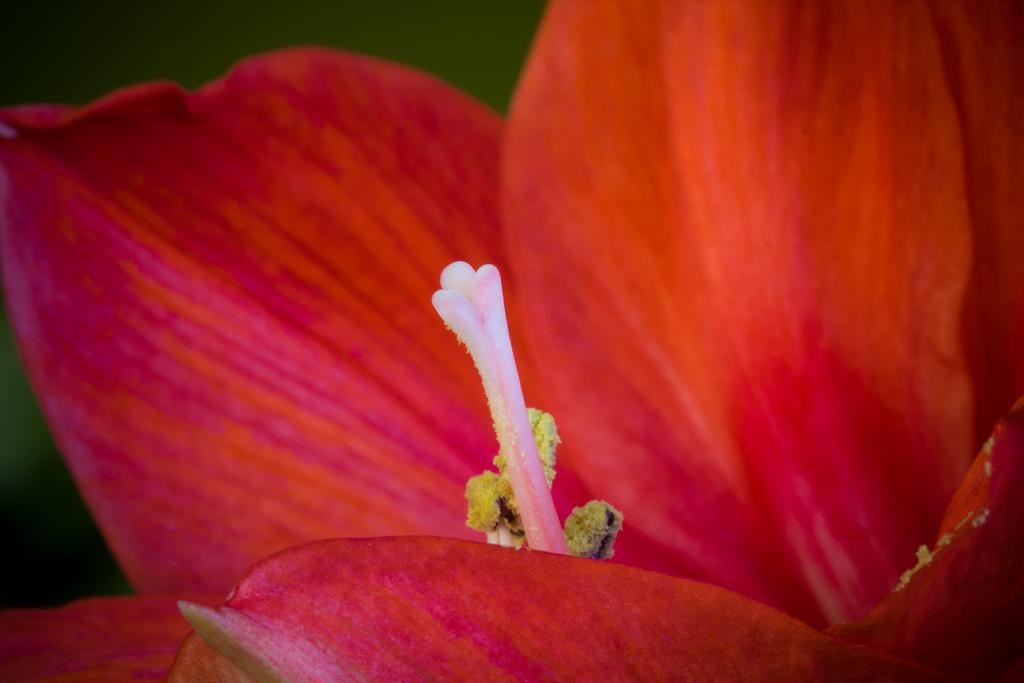What is the main subject of the image? There is a flower in the image. What type of scarf is the flower wearing in the image? There is no scarf present in the image, as flowers do not wear clothing. 